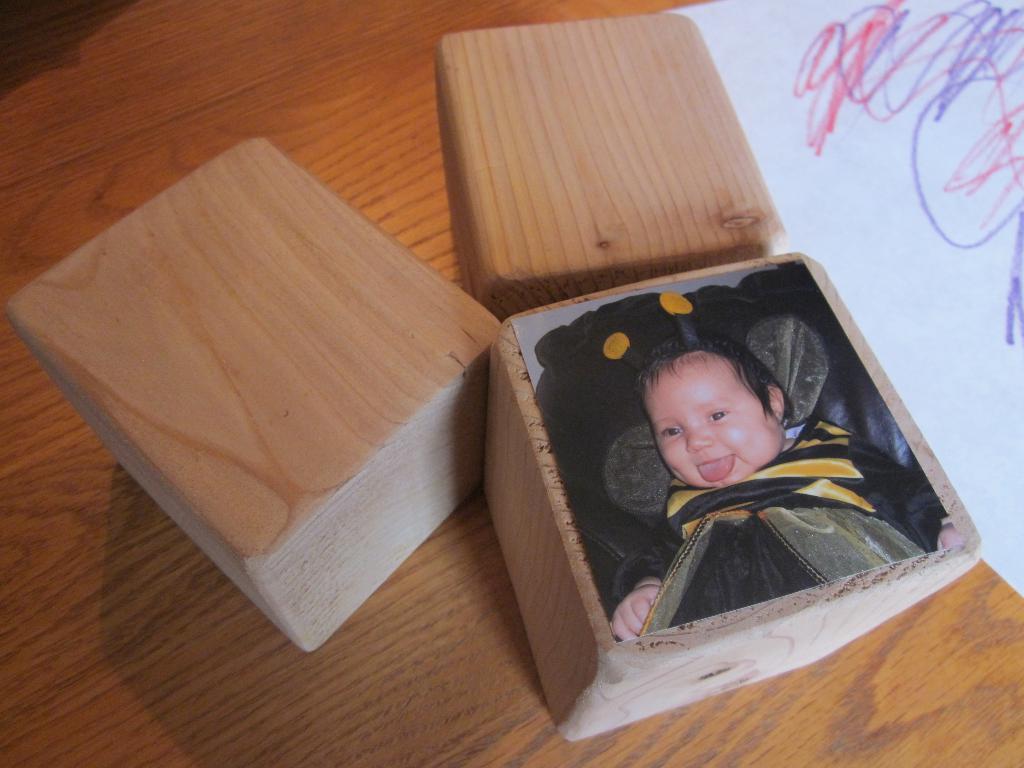Could you give a brief overview of what you see in this image? In this picture we can see wooden objects, paper, photo of a baby smiling and these all are placed on a table. 